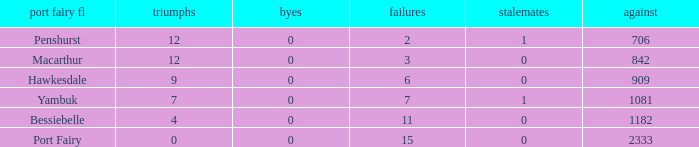How many draws when the Port Fairy FL is Hawkesdale and there are more than 9 wins? None. 